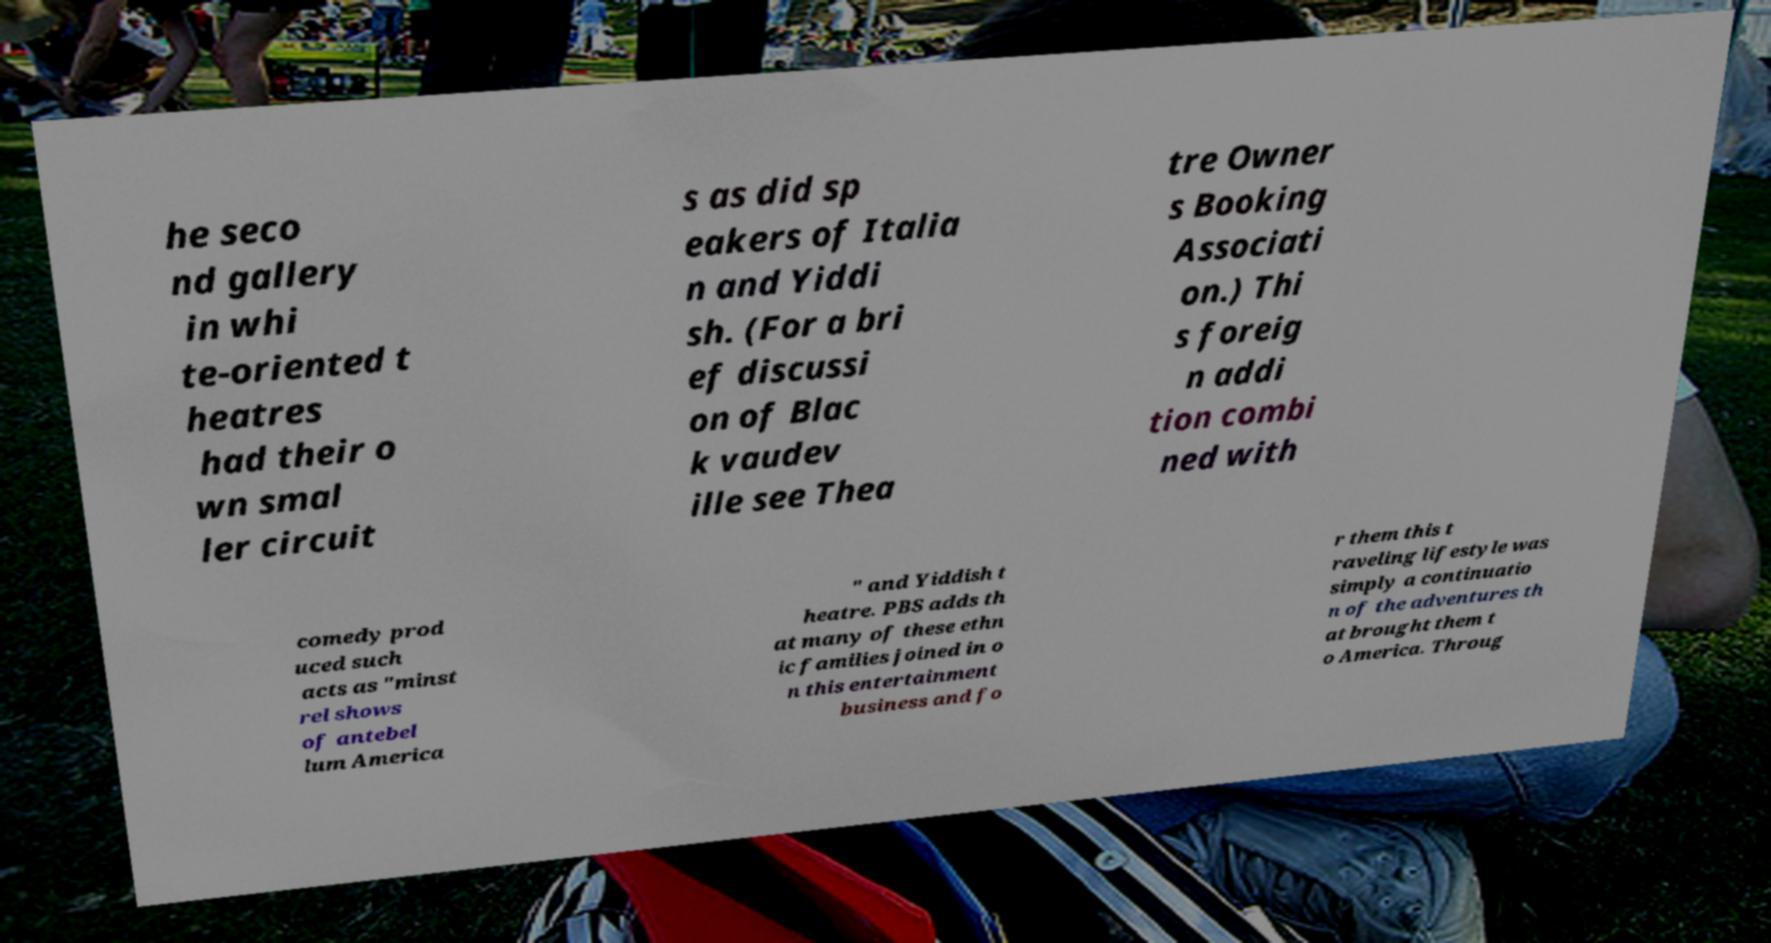Could you assist in decoding the text presented in this image and type it out clearly? he seco nd gallery in whi te-oriented t heatres had their o wn smal ler circuit s as did sp eakers of Italia n and Yiddi sh. (For a bri ef discussi on of Blac k vaudev ille see Thea tre Owner s Booking Associati on.) Thi s foreig n addi tion combi ned with comedy prod uced such acts as "minst rel shows of antebel lum America " and Yiddish t heatre. PBS adds th at many of these ethn ic families joined in o n this entertainment business and fo r them this t raveling lifestyle was simply a continuatio n of the adventures th at brought them t o America. Throug 